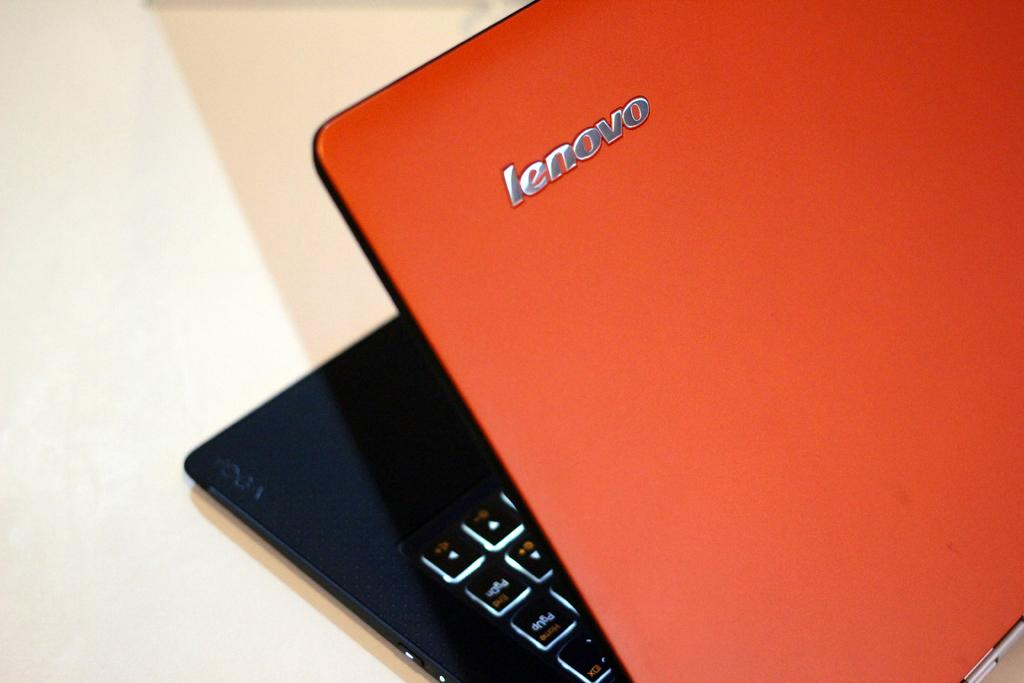<image>
Describe the image concisely. A lenovo laptop has an orange cover and black inside. 